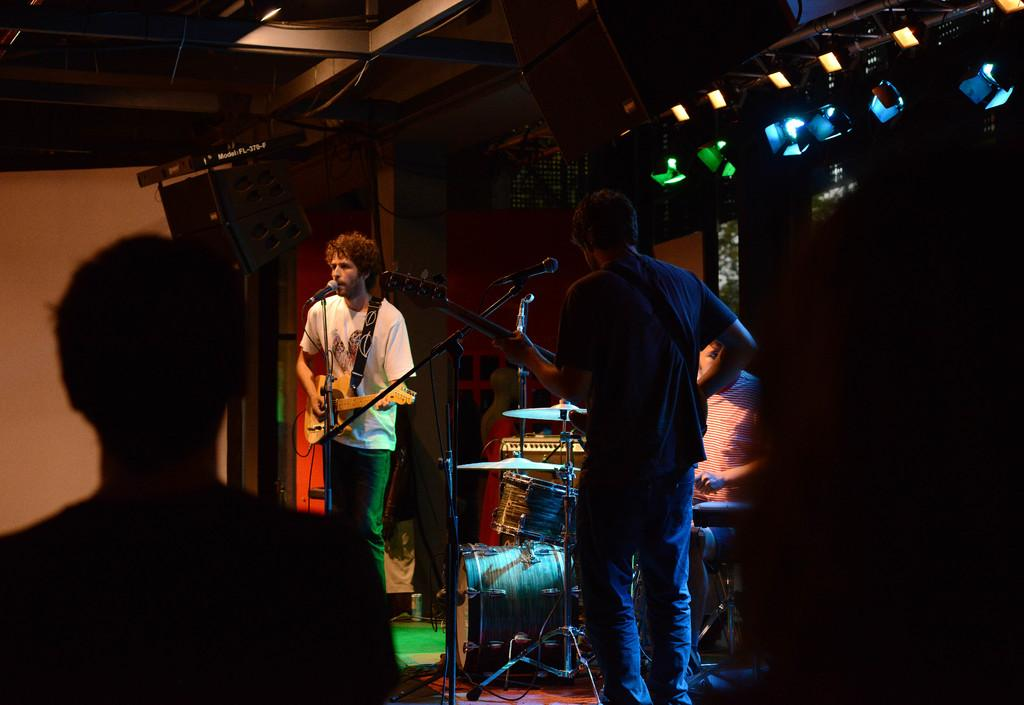How many people are in the image? There are four people in the image. What objects are associated with the people in the image? There is a microphone and a guitar in the image. What activity are the people in the image engaged in? The image depicts a musical band. What else can be seen in the image besides the people and instruments? There are lights in the image. What type of creature is playing the guitar in the image? There is no creature present in the image; it features four people playing instruments as part of a musical band. How many trees can be seen in the image? There are no trees visible in the image. 